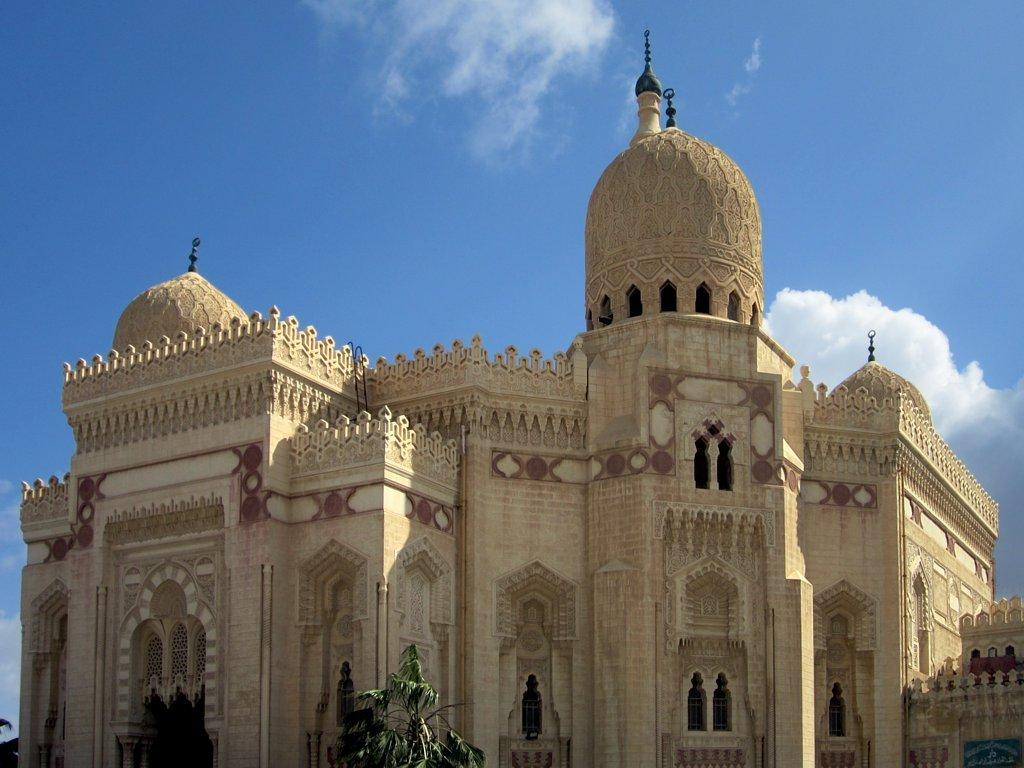What type of structure is in the image? There is a building in the image. What can be seen in the sky at the top of the image? Clouds are visible in the sky at the top of the image. What type of vegetation is at the bottom of the image? There is a tree at the bottom of the image. What feature allows light to enter the building? Windows are present in the image. How many bags of salt are visible in the image? There are no bags of salt present in the image. What type of balls are being used in the game depicted in the image? There is no game or balls depicted in the image. 